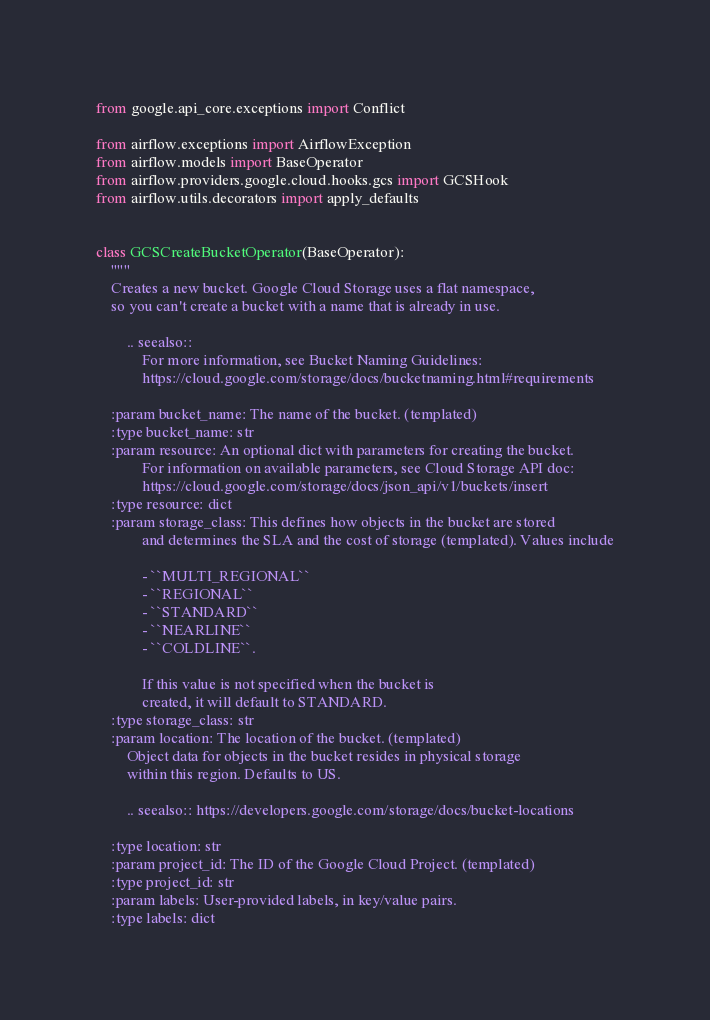Convert code to text. <code><loc_0><loc_0><loc_500><loc_500><_Python_>from google.api_core.exceptions import Conflict

from airflow.exceptions import AirflowException
from airflow.models import BaseOperator
from airflow.providers.google.cloud.hooks.gcs import GCSHook
from airflow.utils.decorators import apply_defaults


class GCSCreateBucketOperator(BaseOperator):
    """
    Creates a new bucket. Google Cloud Storage uses a flat namespace,
    so you can't create a bucket with a name that is already in use.

        .. seealso::
            For more information, see Bucket Naming Guidelines:
            https://cloud.google.com/storage/docs/bucketnaming.html#requirements

    :param bucket_name: The name of the bucket. (templated)
    :type bucket_name: str
    :param resource: An optional dict with parameters for creating the bucket.
            For information on available parameters, see Cloud Storage API doc:
            https://cloud.google.com/storage/docs/json_api/v1/buckets/insert
    :type resource: dict
    :param storage_class: This defines how objects in the bucket are stored
            and determines the SLA and the cost of storage (templated). Values include

            - ``MULTI_REGIONAL``
            - ``REGIONAL``
            - ``STANDARD``
            - ``NEARLINE``
            - ``COLDLINE``.

            If this value is not specified when the bucket is
            created, it will default to STANDARD.
    :type storage_class: str
    :param location: The location of the bucket. (templated)
        Object data for objects in the bucket resides in physical storage
        within this region. Defaults to US.

        .. seealso:: https://developers.google.com/storage/docs/bucket-locations

    :type location: str
    :param project_id: The ID of the Google Cloud Project. (templated)
    :type project_id: str
    :param labels: User-provided labels, in key/value pairs.
    :type labels: dict</code> 